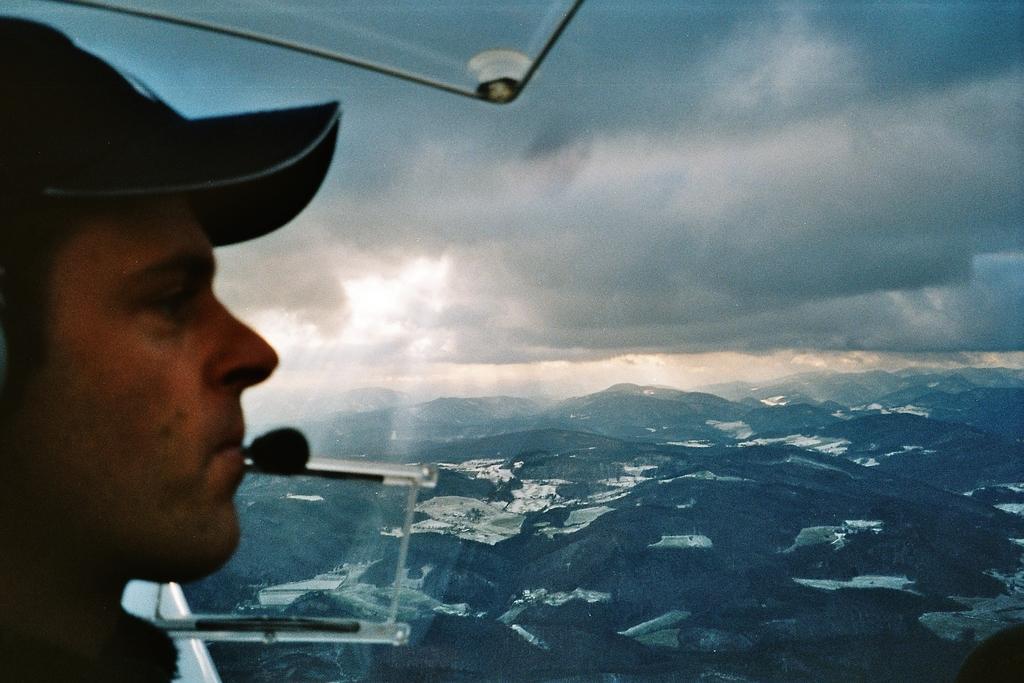Can you describe this image briefly? In this image, we can see a man wearing a hat, at the top there is a sky. 